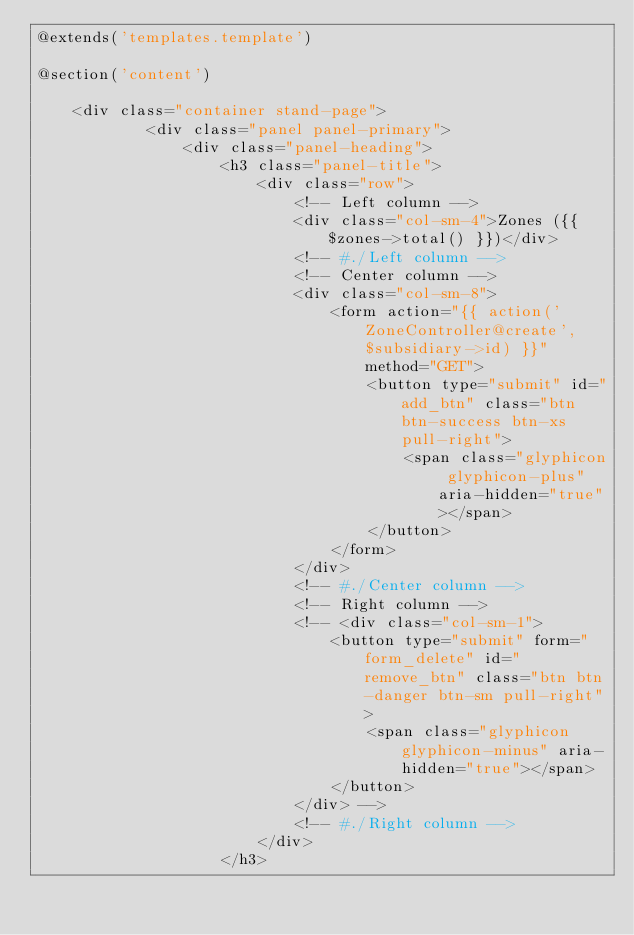Convert code to text. <code><loc_0><loc_0><loc_500><loc_500><_PHP_>@extends('templates.template')

@section('content')

	<div class="container stand-page">
			<div class="panel panel-primary">
				<div class="panel-heading">
					<h3 class="panel-title">
						<div class="row">
							<!-- Left column -->
							<div class="col-sm-4">Zones ({{ $zones->total() }})</div>
							<!-- #./Left column -->
							<!-- Center column -->
							<div class="col-sm-8">
								<form action="{{ action('ZoneController@create', $subsidiary->id) }}" method="GET">
									<button type="submit" id="add_btn" class="btn btn-success btn-xs pull-right">
										<span class="glyphicon glyphicon-plus" aria-hidden="true"></span>
									</button>
								</form>
							</div>
							<!-- #./Center column -->
							<!-- Right column -->
							<!-- <div class="col-sm-1">
								<button type="submit" form="form_delete" id="remove_btn" class="btn btn-danger btn-sm pull-right">
									<span class="glyphicon glyphicon-minus" aria-hidden="true"></span>
								</button>
							</div> -->
							<!-- #./Right column -->
						</div>
					</h3></code> 